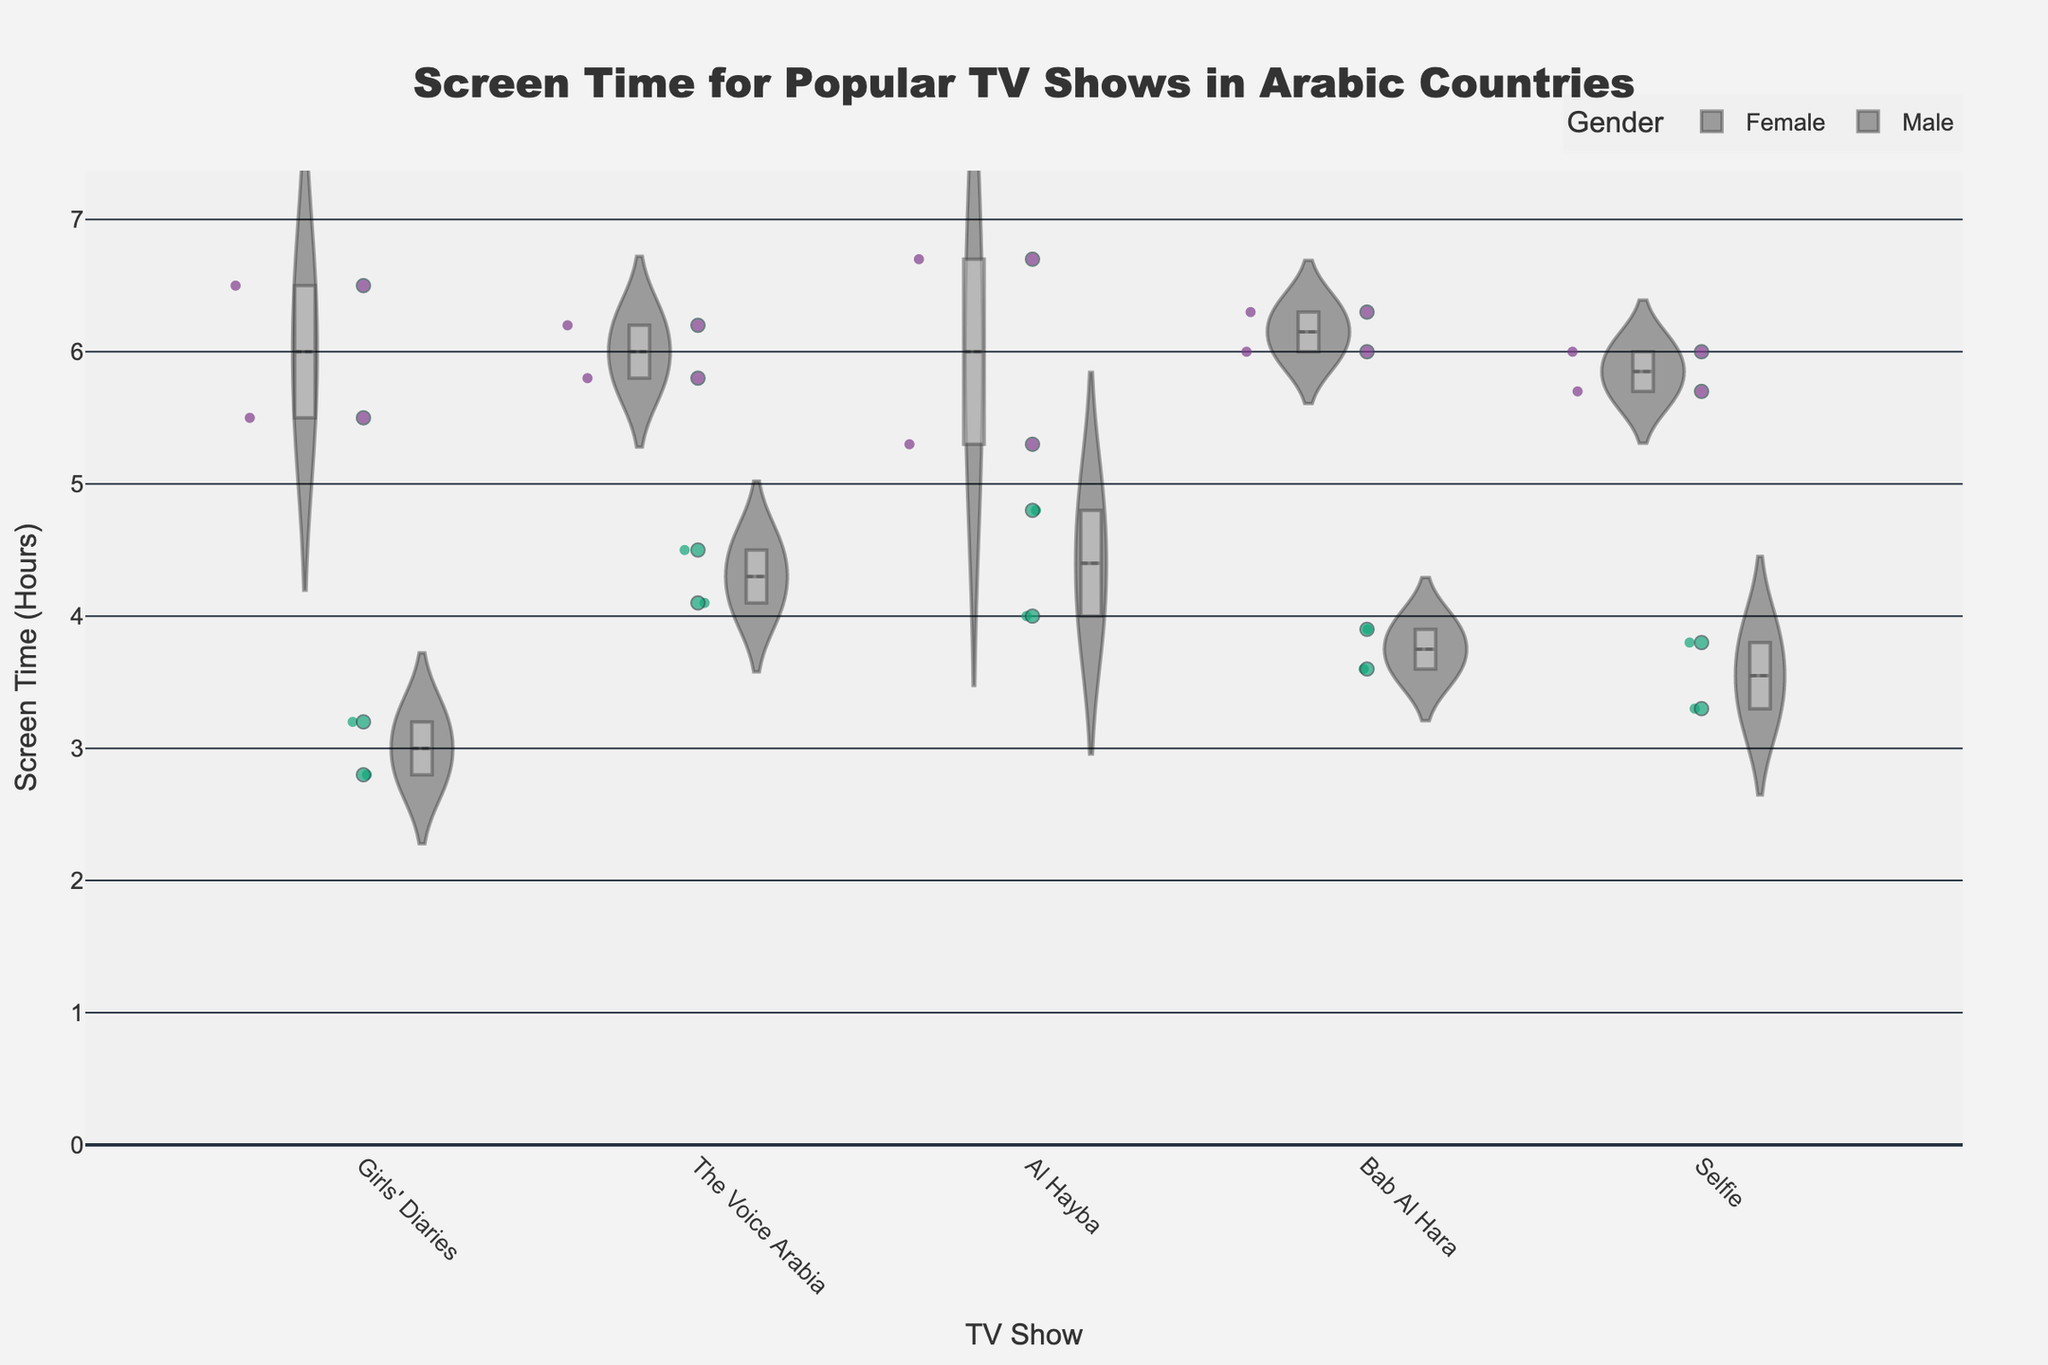What is the title of the figure? The title is usually displayed at the top of the figure. Here, the title text is centered and reads "Screen Time for Popular TV Shows in Arabic Countries".
Answer: Screen Time for Popular TV Shows in Arabic Countries Which TV show had the highest maximum screen time for females? To determine the highest maximum screen time, observe the range of the violin plots for each TV show. For females, the plot with the highest peak indicates the maximum screen time.
Answer: Al Hayba What is the average screen time for males in the age group 18-24 for the TV show "Girls' Diaries"? Average screen time can be calculated by summing the screen time values and dividing by the number of data points. For "Girls' Diaries", the screen times for males in the age group 18-24 are shown around the jittered points. There's only one data point at 3.2 hours. So, the average is 3.2.
Answer: 3.2 hours How does the median screen time for "Bab Al Hara" compare between males and females? The median is indicated by the white dot in the center of each violin plot. Compare the position of the white dots in the "Bab Al Hara" plots for males and females.
Answer: The median for females is higher than for males What is the spread of screen time for "The Voice Arabia" for both genders? The spread refers to the range of values the data points cover in the violin plot. Observe the "The Voice Arabia" violin plots and note the range from the minimum to maximum values for both genders (around 4-6 hours for females and 4-5 hours for males).
Answer: 4-6 hours for females, 4-5 hours for males Which age group and gender in the United Arab Emirates watches "Al Hayba" the most? Review the hover data points for "Al Hayba" in the United Arab Emirates. The highest point in the violin plot or the point with the maximum jitter value indicates the group with the highest screen time. For females aged 18-24, the screen time is at the top around 6.7 hours.
Answer: Females, 18-24 Is there more variability in screen time for "Selfie" between different genders or age groups? Variability can be seen by the width and spread of the violin plots. Compare the width and spread of the "Selfie" violin plots across genders and age groups. If the plots for different age groups differ more than those of different genders, age groups have more variability.
Answer: Age groups Which TV show appears to have the most balanced screen time between males and females? Balanced screen time means the violin plots for males and females are similar in shape and size. Observing the plots for all shows, "The Voice Arabia" seems the most balanced due to the similar spreads and median values.
Answer: The Voice Arabia What is the range of screen time for the age group 25-34 watching "Bab Al Hara"? The range is the difference between the maximum and minimum values. Look at the jittered points and the extents of the violin plot for the 25-34 age group and "Bab Al Hara". The points show a minimum around 3.9 and a maximum around 6 hours.
Answer: 3.9 to 6 hours How does the mean line for males compare to the mean line for females in "Girls' Diaries"? The mean line is a solid line within each violin plot. Compare the position of the mean lines in the "Girls' Diaries" plots for both genders. The males have a lower mean line compared to females.
Answer: Lower for males than females 